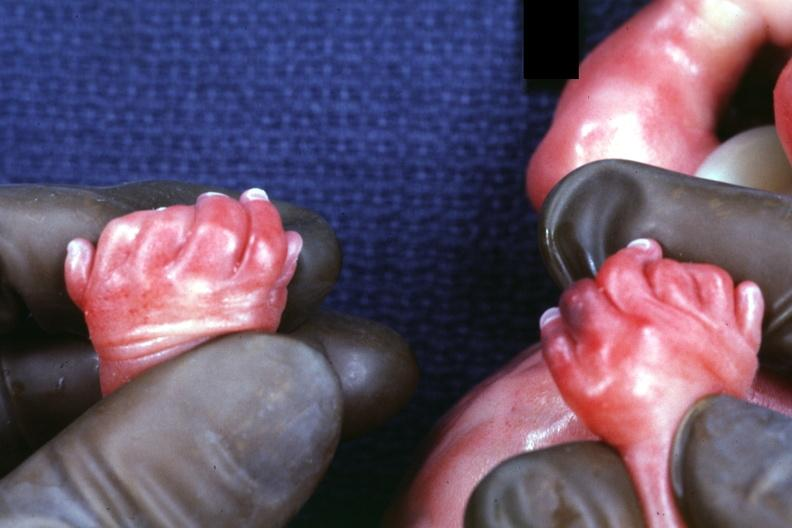what are present?
Answer the question using a single word or phrase. Extremities 